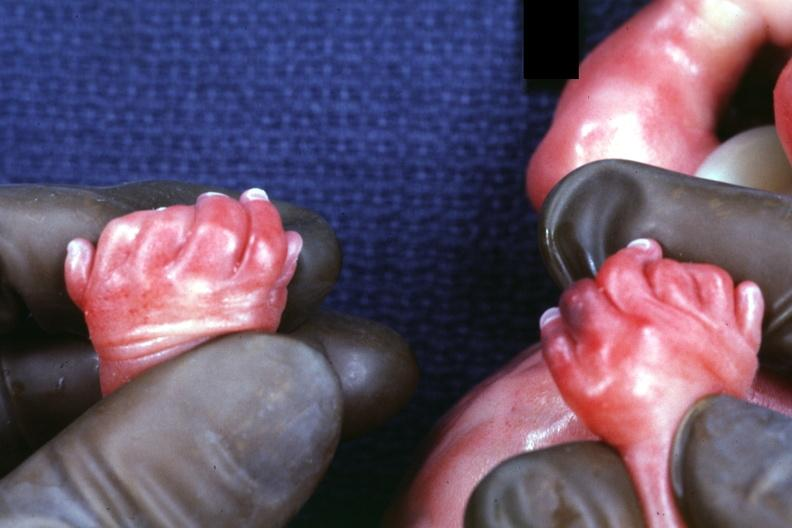what are present?
Answer the question using a single word or phrase. Extremities 